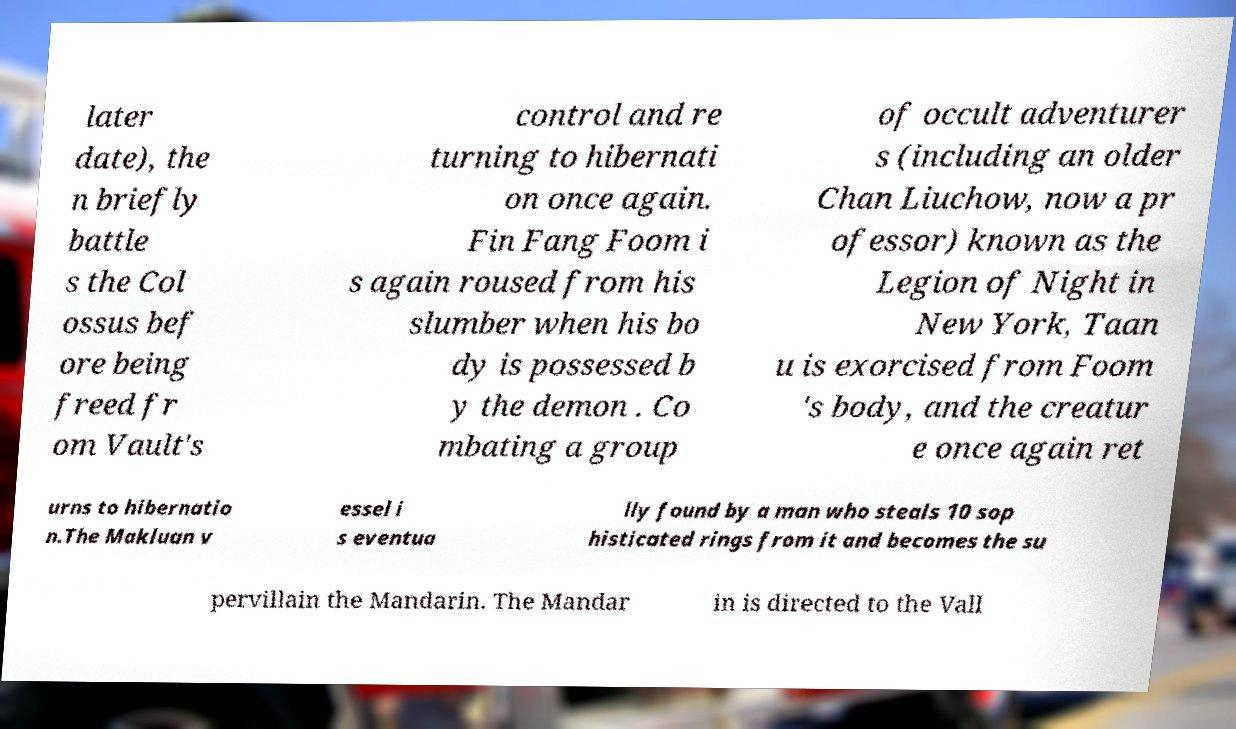Please read and relay the text visible in this image. What does it say? later date), the n briefly battle s the Col ossus bef ore being freed fr om Vault's control and re turning to hibernati on once again. Fin Fang Foom i s again roused from his slumber when his bo dy is possessed b y the demon . Co mbating a group of occult adventurer s (including an older Chan Liuchow, now a pr ofessor) known as the Legion of Night in New York, Taan u is exorcised from Foom 's body, and the creatur e once again ret urns to hibernatio n.The Makluan v essel i s eventua lly found by a man who steals 10 sop histicated rings from it and becomes the su pervillain the Mandarin. The Mandar in is directed to the Vall 